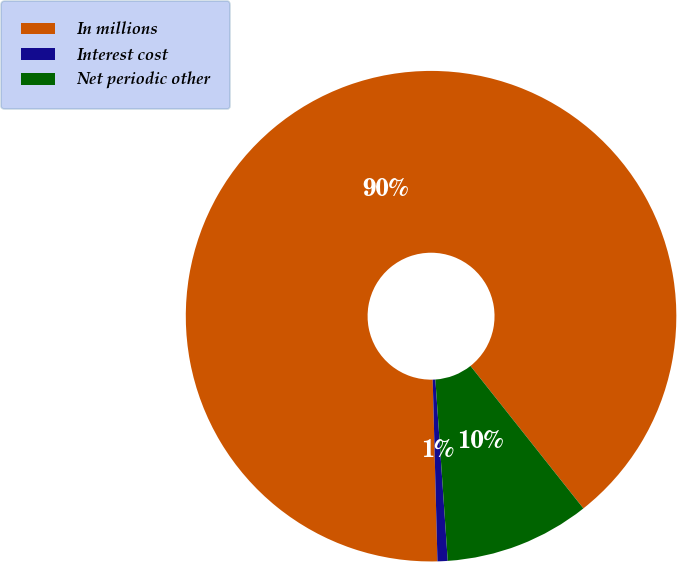Convert chart. <chart><loc_0><loc_0><loc_500><loc_500><pie_chart><fcel>In millions<fcel>Interest cost<fcel>Net periodic other<nl><fcel>89.76%<fcel>0.67%<fcel>9.58%<nl></chart> 